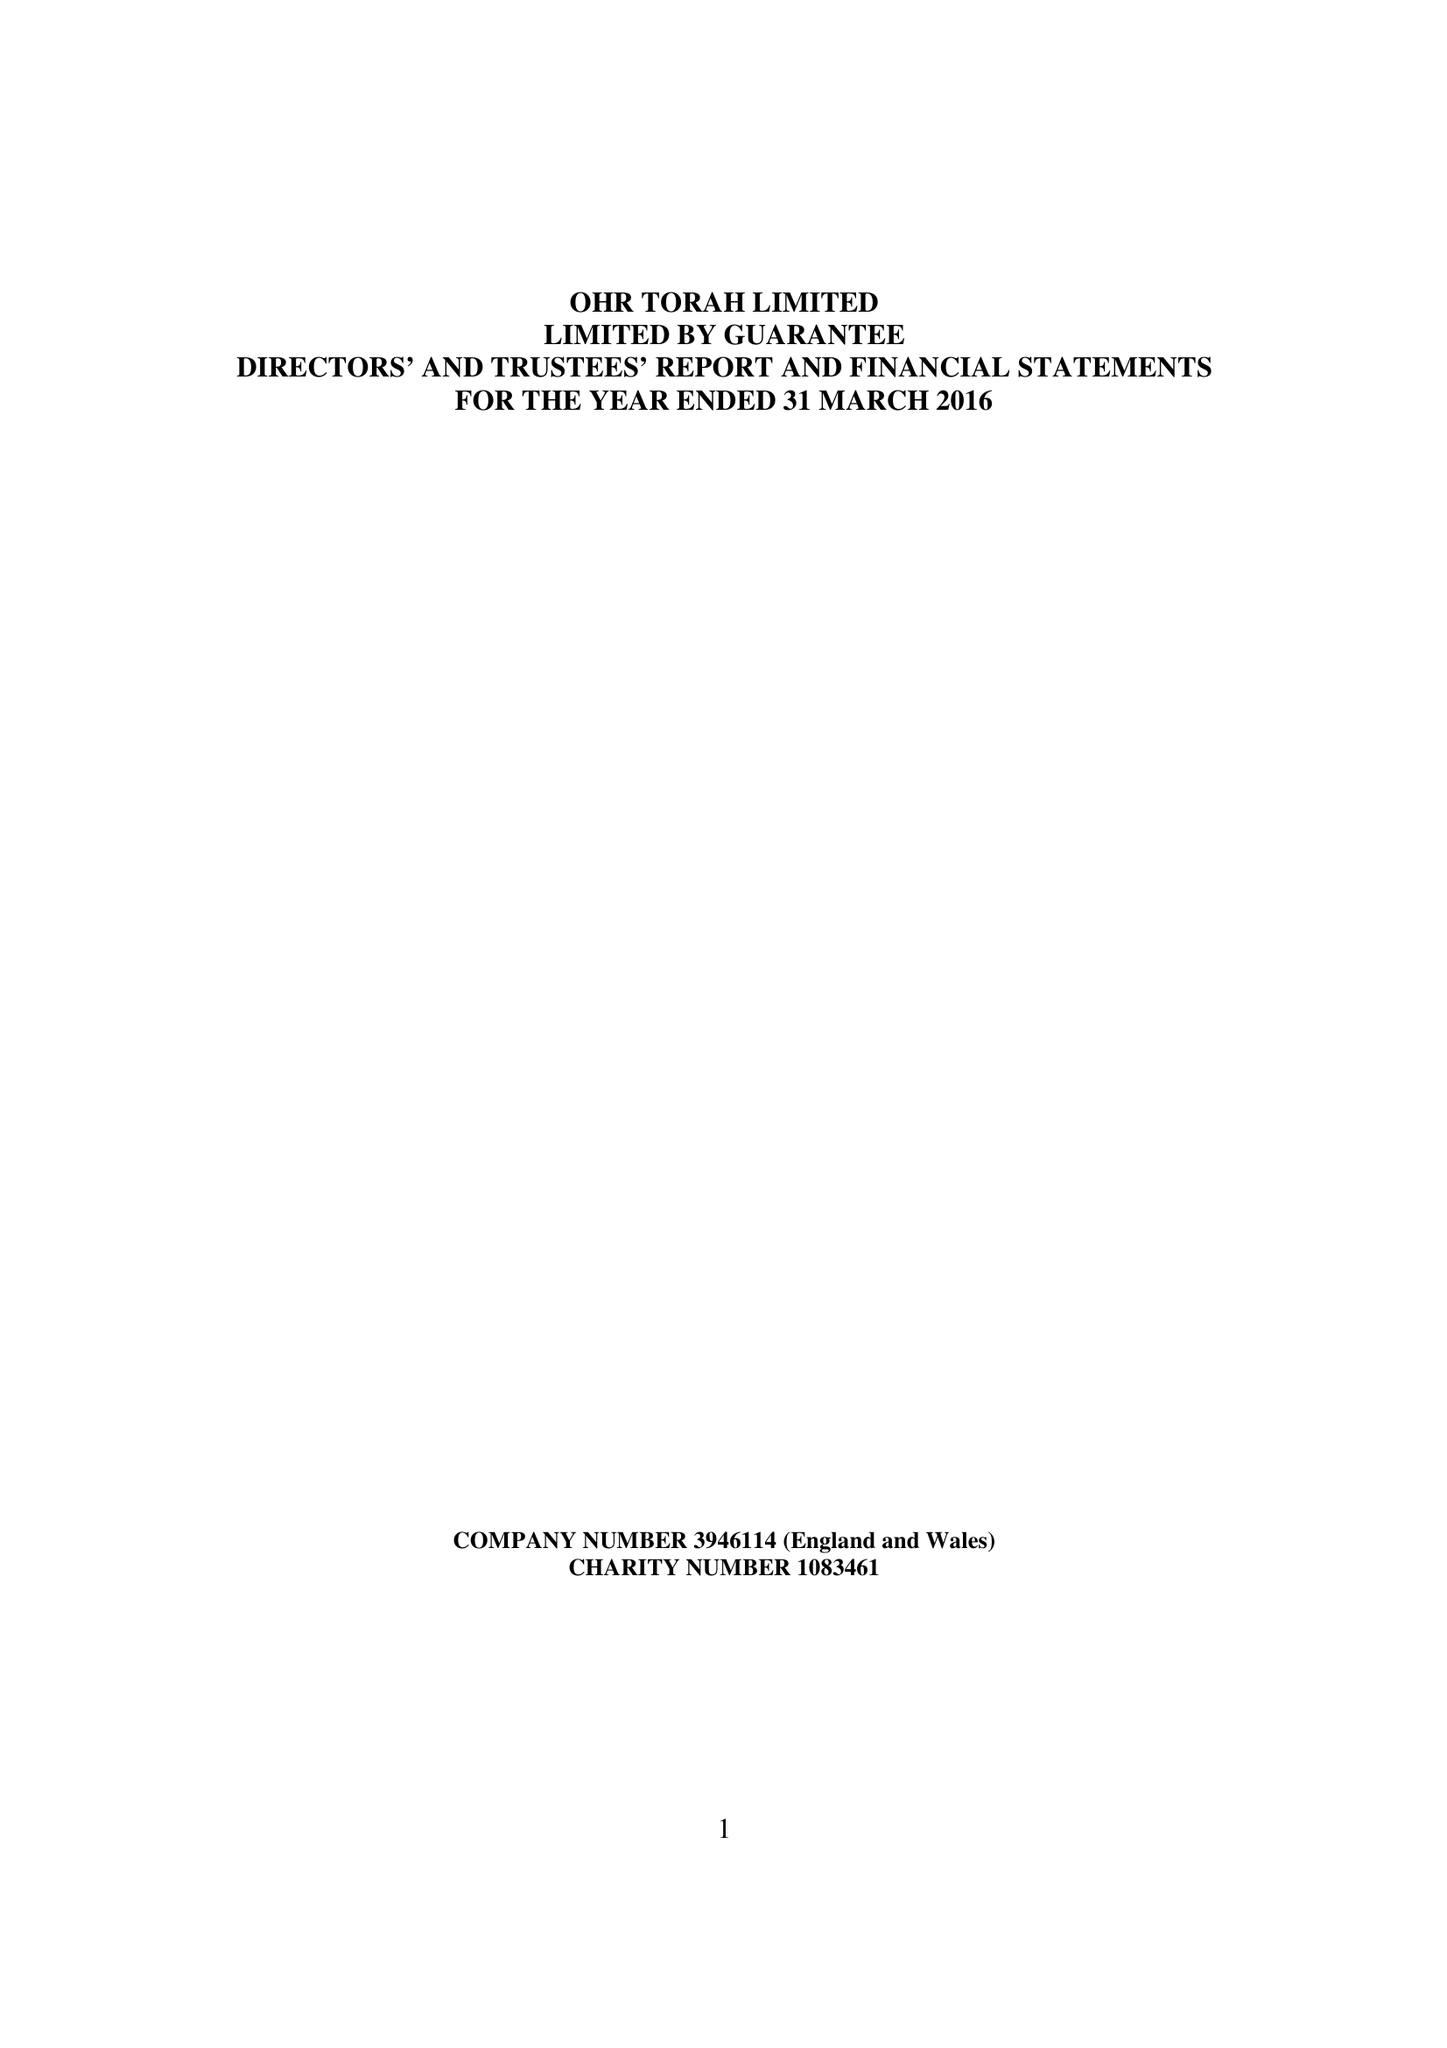What is the value for the income_annually_in_british_pounds?
Answer the question using a single word or phrase. 77001.00 